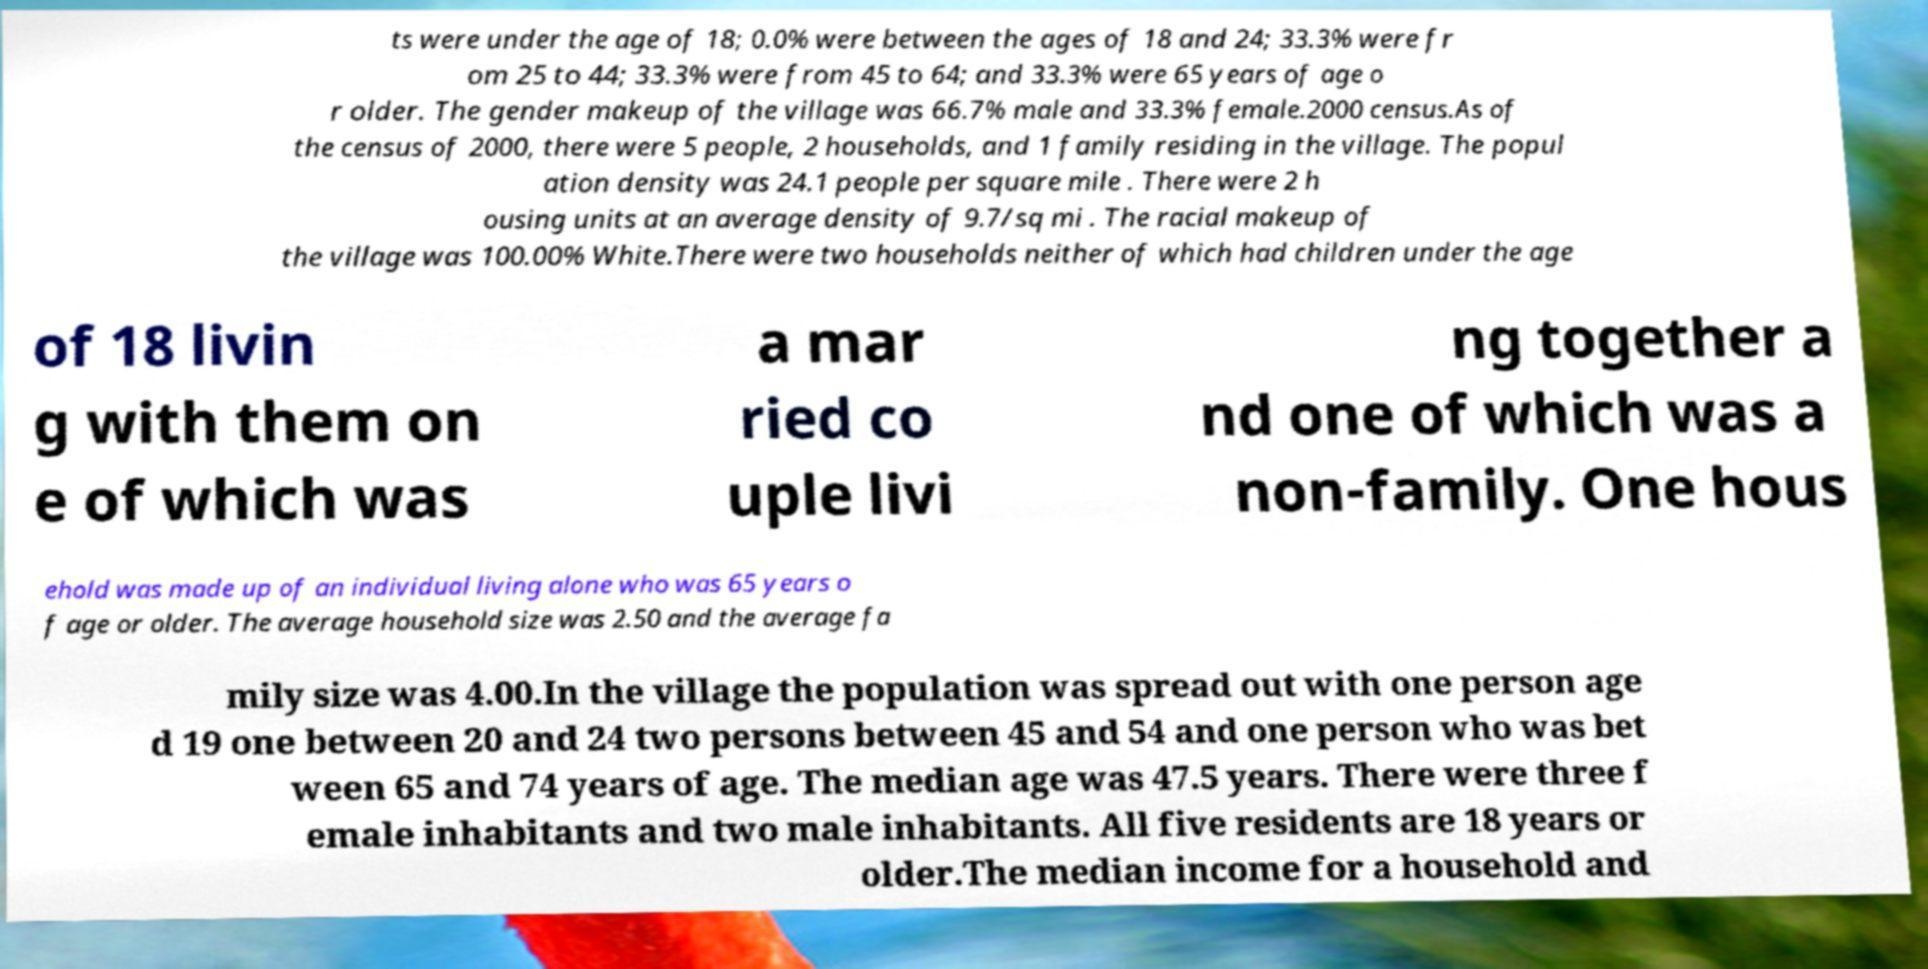Could you extract and type out the text from this image? ts were under the age of 18; 0.0% were between the ages of 18 and 24; 33.3% were fr om 25 to 44; 33.3% were from 45 to 64; and 33.3% were 65 years of age o r older. The gender makeup of the village was 66.7% male and 33.3% female.2000 census.As of the census of 2000, there were 5 people, 2 households, and 1 family residing in the village. The popul ation density was 24.1 people per square mile . There were 2 h ousing units at an average density of 9.7/sq mi . The racial makeup of the village was 100.00% White.There were two households neither of which had children under the age of 18 livin g with them on e of which was a mar ried co uple livi ng together a nd one of which was a non-family. One hous ehold was made up of an individual living alone who was 65 years o f age or older. The average household size was 2.50 and the average fa mily size was 4.00.In the village the population was spread out with one person age d 19 one between 20 and 24 two persons between 45 and 54 and one person who was bet ween 65 and 74 years of age. The median age was 47.5 years. There were three f emale inhabitants and two male inhabitants. All five residents are 18 years or older.The median income for a household and 